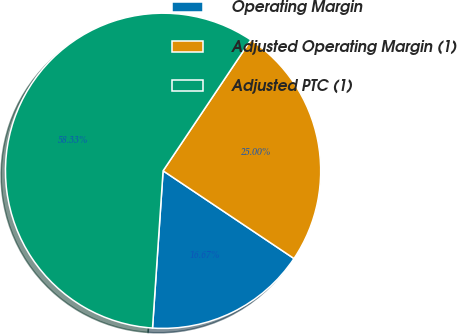<chart> <loc_0><loc_0><loc_500><loc_500><pie_chart><fcel>Operating Margin<fcel>Adjusted Operating Margin (1)<fcel>Adjusted PTC (1)<nl><fcel>16.67%<fcel>25.0%<fcel>58.33%<nl></chart> 